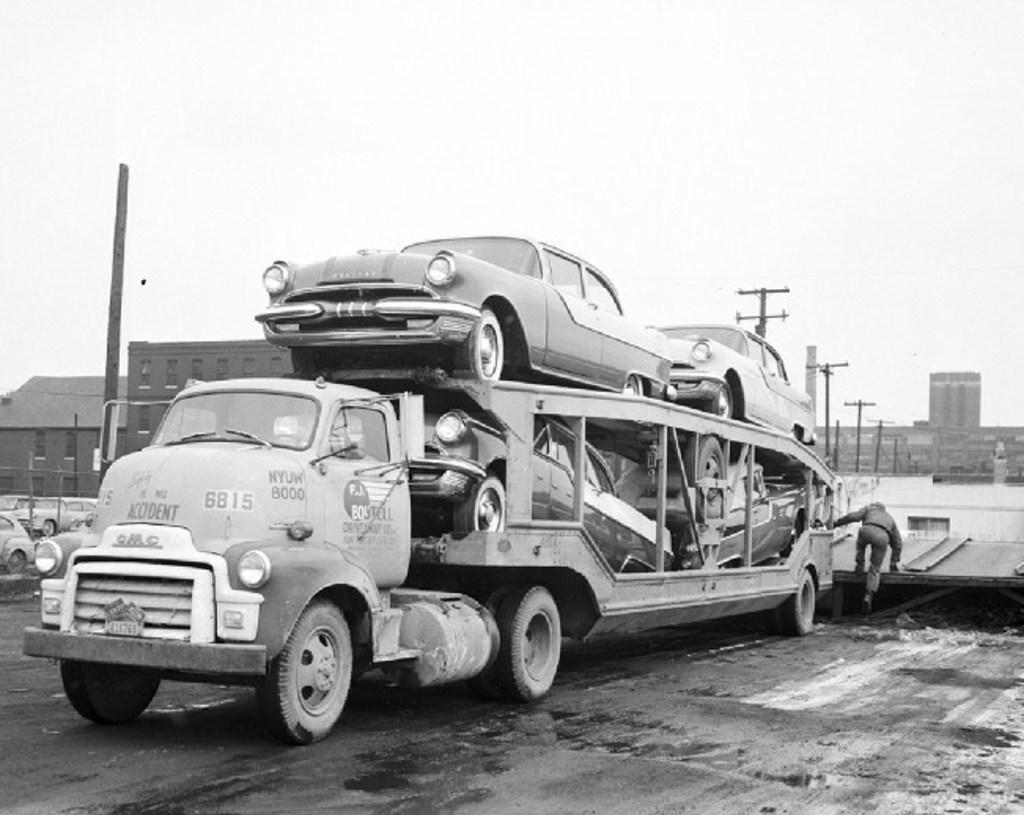What types of objects are present in the image? There are vehicles, a person, buildings, and poles in the image. Can you describe the person in the image? There is a person in the image, but no specific details about their appearance or actions are provided. What can be seen in the background of the image? The sky is visible in the background of the image. How many horses are present in the image? There are no horses present in the image. What side of the person is facing the camera in the image? The provided facts do not specify which side of the person is facing the camera, if any. 